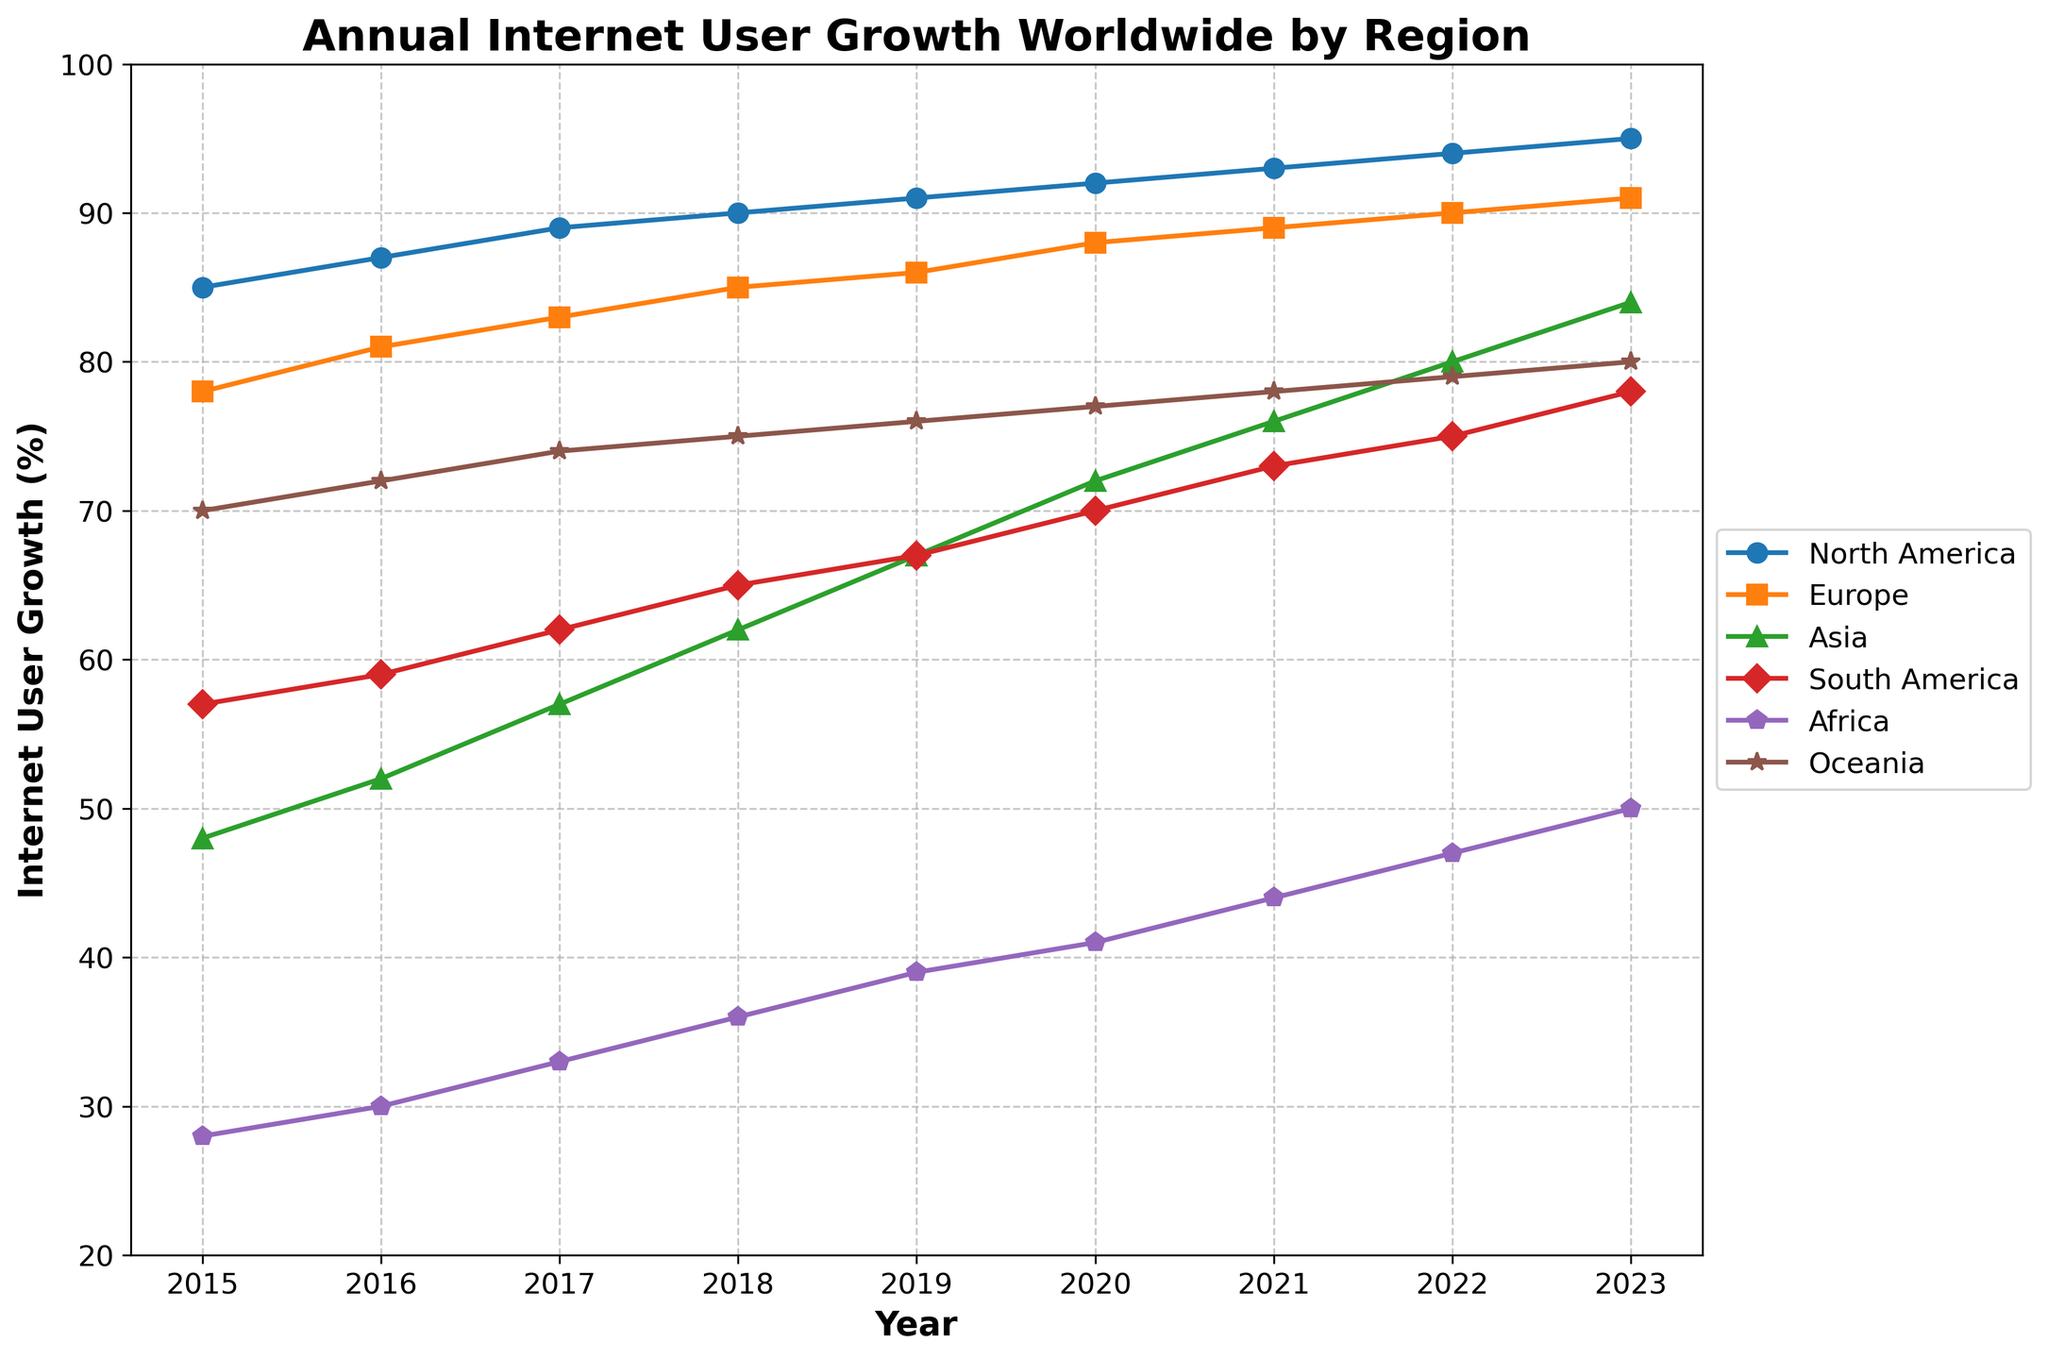What is the title of the figure? The title of the figure is displayed at the top of the plot.
Answer: Annual Internet User Growth Worldwide by Region What is the trend for North America's internet user growth from 2015 to 2023? By observing the lines on the plot, we can see the progression of North America's internet user growth over the years, which consistently increases.
Answer: Consistently increasing Which region had the highest internet user growth in 2023? By looking at the final data points on the right side of the plot for each region, we can compare their values. North America has the highest value.
Answer: North America How many regions are represented in the plot? We count the number of lines or legend entries, each representing a region.
Answer: 6 What was the internet user growth in Africa in 2020? Locate the data point corresponding to Africa in the year 2020 on the plot.
Answer: 41% Compare the internet user growth in Europe and Asia in 2016. Which one was higher? By comparing the data points for Europe and Asia in the year 2016, we see which is higher. Europe has 81% and Asia has 52%, so Europe is higher.
Answer: Europe By how much did the internet user growth in Oceania increase from 2015 to 2023? Locate the data points for Oceania for the years 2015 and 2023, then subtract the former's value from the latter's value.
Answer: 10% In which year did South America surpass 70% internet user growth? Trace the data points for South America over the years until you find the first instance of a value above 70%. The year is 2020.
Answer: 2020 Which region showed the most significant growth in internet users from 2015 to 2023? Calculate the difference between the 2023 and 2015 data points for each region and compare them. Asia shows the most significant growth (84% - 48% = 36%).
Answer: Asia 